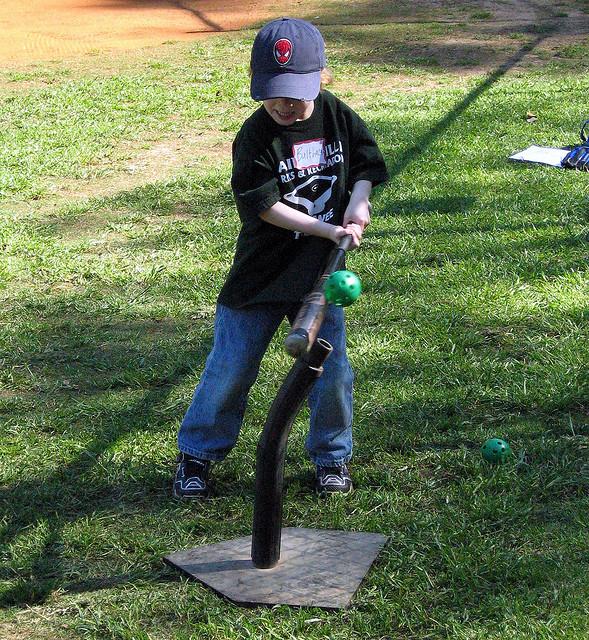Is the boy in the photograph wearing a baseball cap?
Give a very brief answer. Yes. What is the boy standing next to?
Keep it brief. Baseball tee. Which letter of the alphabet is this game named after?
Concise answer only. B. What is the approximate age of the child?
Quick response, please. 6. 